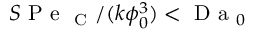Convert formula to latex. <formula><loc_0><loc_0><loc_500><loc_500>S P e _ { C } / ( k \phi _ { 0 } ^ { 3 } ) < D a _ { 0 }</formula> 